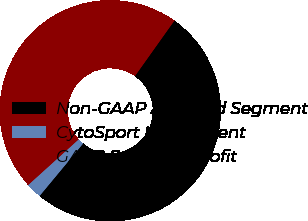<chart> <loc_0><loc_0><loc_500><loc_500><pie_chart><fcel>Non-GAAP Adjusted Segment<fcel>CytoSport Impairment<fcel>GAAP Segment Profit<nl><fcel>51.19%<fcel>2.28%<fcel>46.54%<nl></chart> 